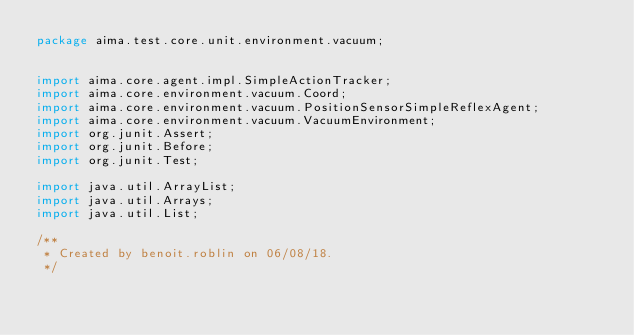Convert code to text. <code><loc_0><loc_0><loc_500><loc_500><_Java_>package aima.test.core.unit.environment.vacuum;


import aima.core.agent.impl.SimpleActionTracker;
import aima.core.environment.vacuum.Coord;
import aima.core.environment.vacuum.PositionSensorSimpleReflexAgent;
import aima.core.environment.vacuum.VacuumEnvironment;
import org.junit.Assert;
import org.junit.Before;
import org.junit.Test;

import java.util.ArrayList;
import java.util.Arrays;
import java.util.List;

/**
 * Created by benoit.roblin on 06/08/18.
 */</code> 